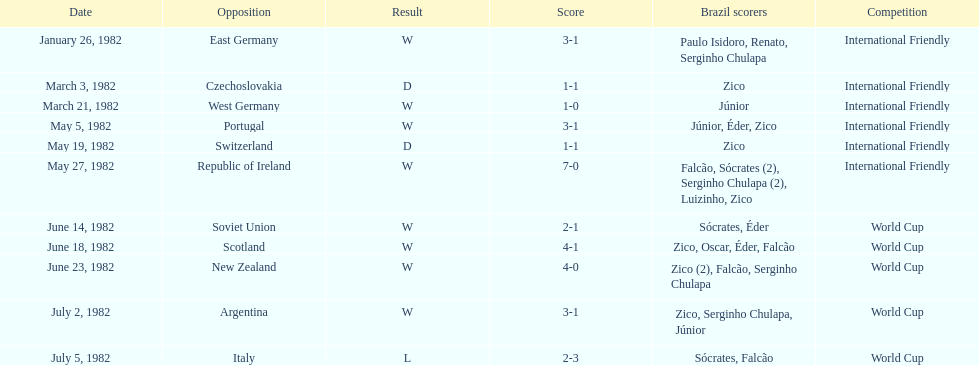What date is at the top of the list? January 26, 1982. 